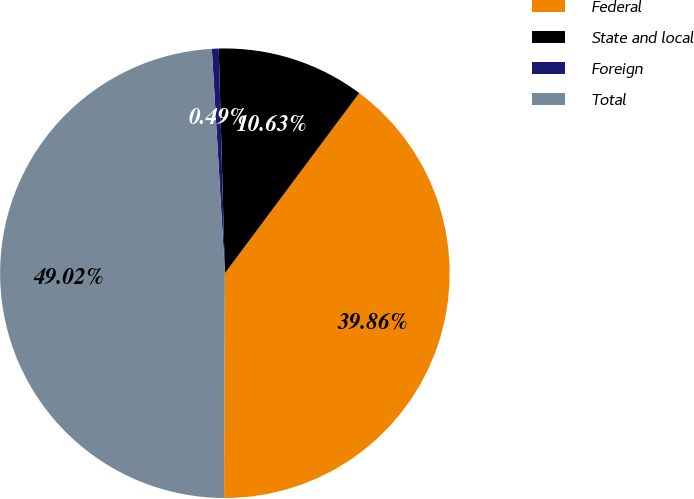Convert chart. <chart><loc_0><loc_0><loc_500><loc_500><pie_chart><fcel>Federal<fcel>State and local<fcel>Foreign<fcel>Total<nl><fcel>39.86%<fcel>10.63%<fcel>0.49%<fcel>49.02%<nl></chart> 